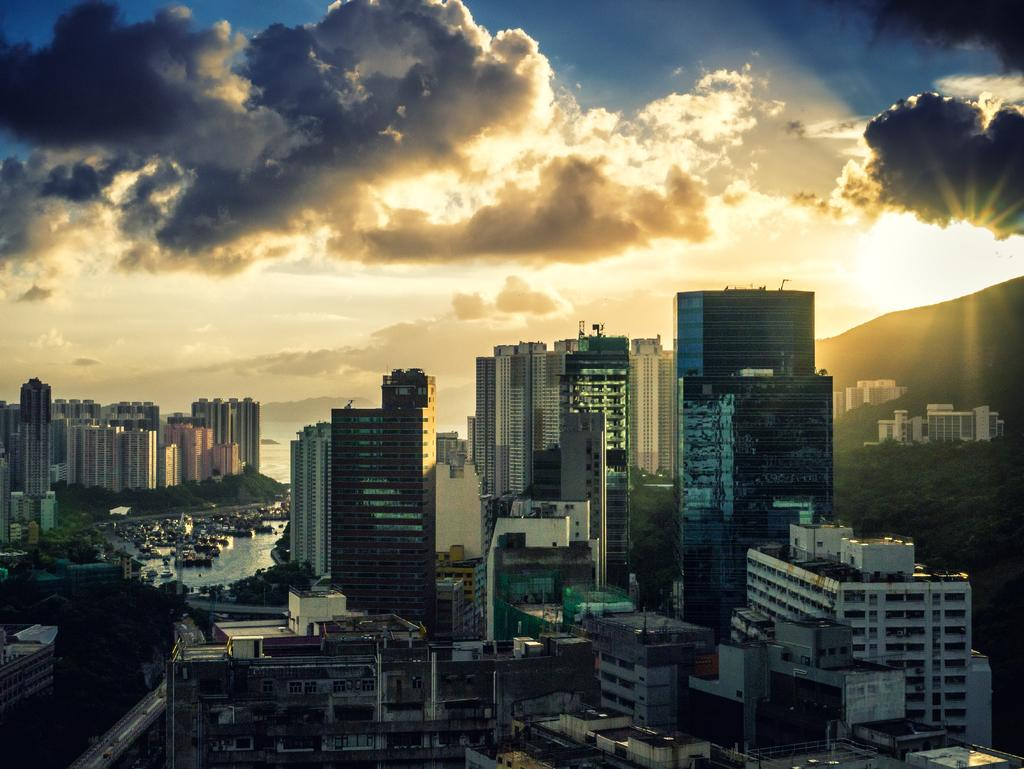What type of structures can be seen in the image? There are buildings in the image. What natural element is visible in the image? There is water visible in the image. What else can be seen in the image besides buildings and water? There are objects in the image. How would you describe the sky in the background of the image? The sky in the background is cloudy. Can you tell me how much friction the stranger is experiencing while walking on the water in the image? There is no stranger present in the image, and walking on water is not physically possible, so friction cannot be determined in this context. 